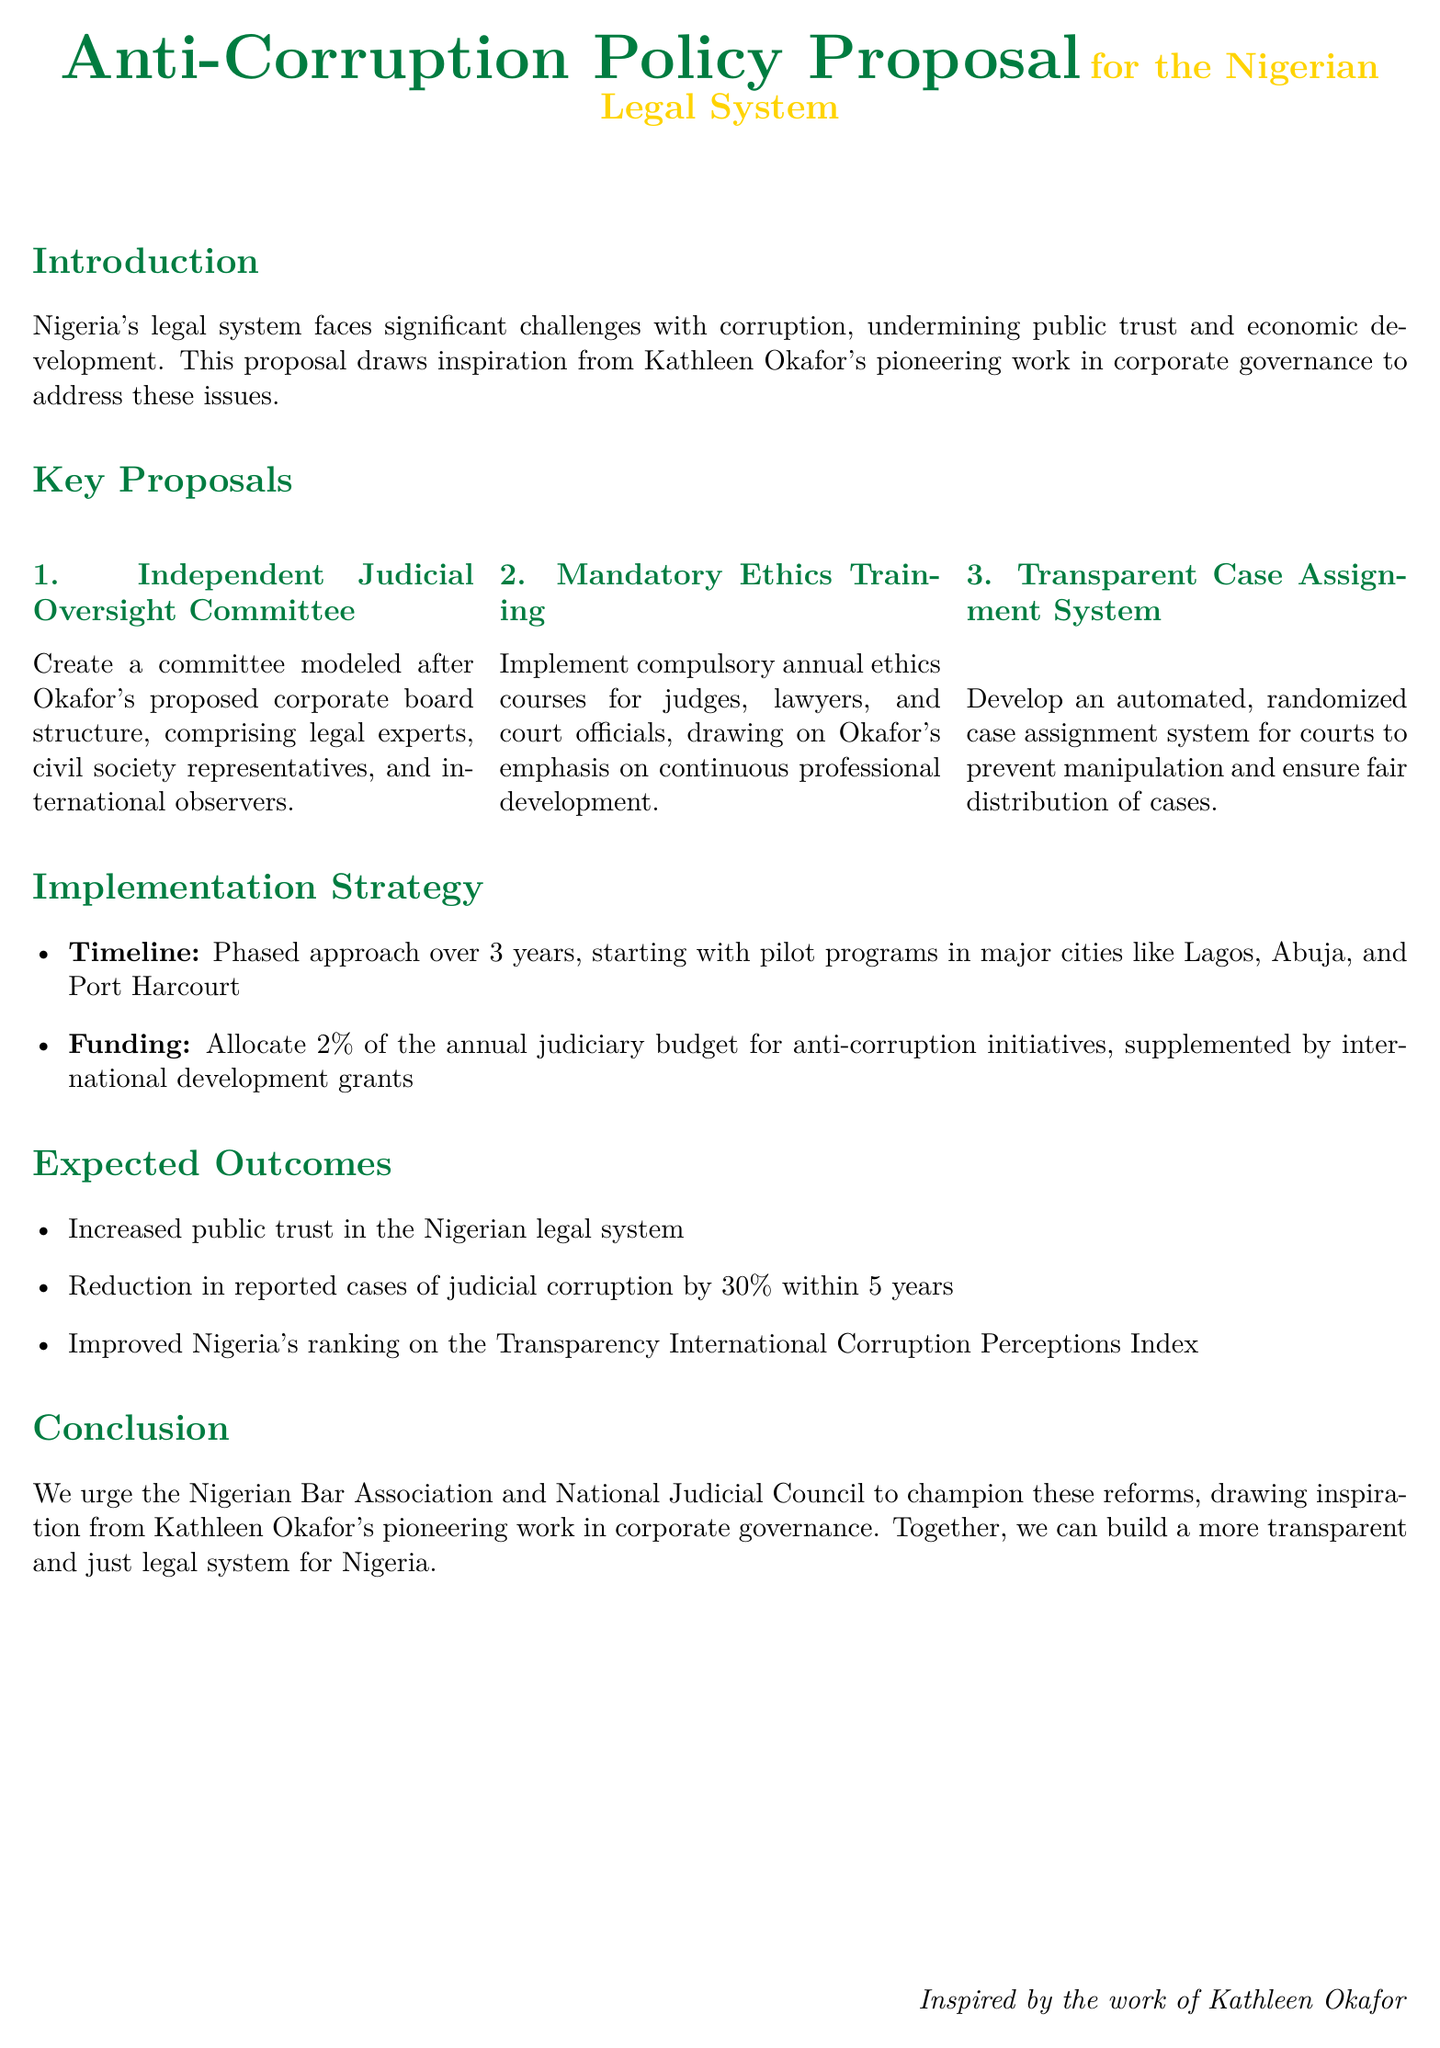What is the main focus of the anti-corruption policy proposal? The main focus of the proposal is to address corruption in Nigeria's legal system.
Answer: Corruption What is the proposed timeline for implementation? The proposal outlines a phased approach over 3 years for implementation.
Answer: 3 years Who is inspired by the work included in the proposal? The proposal draws inspiration from Kathleen Okafor's work in corporate governance.
Answer: Kathleen Okafor What percentage of the annual judiciary budget is suggested for funding anti-corruption initiatives? The document suggests allocating 2% of the annual judiciary budget for these initiatives.
Answer: 2% What is one expected outcome related to public trust? One expected outcome is increased public trust in the Nigerian legal system.
Answer: Increased public trust What type of training is proposed for judges, lawyers, and court officials? The proposal includes mandatory annual ethics training for these professionals.
Answer: Mandatory annual ethics training What is the expected reduction in judicial corruption cases within five years? The proposal aims for a 30% reduction in reported cases of judicial corruption.
Answer: 30% What structure is suggested for the Independent Judicial Oversight Committee? The committee is modeled after a corporate board structure comprising legal experts, civil society representatives, and international observers.
Answer: Corporate board structure What is the goal of implementing a transparent case assignment system? The goal is to prevent manipulation and ensure fair distribution of cases in courts.
Answer: Prevent manipulation and ensure fair distribution 